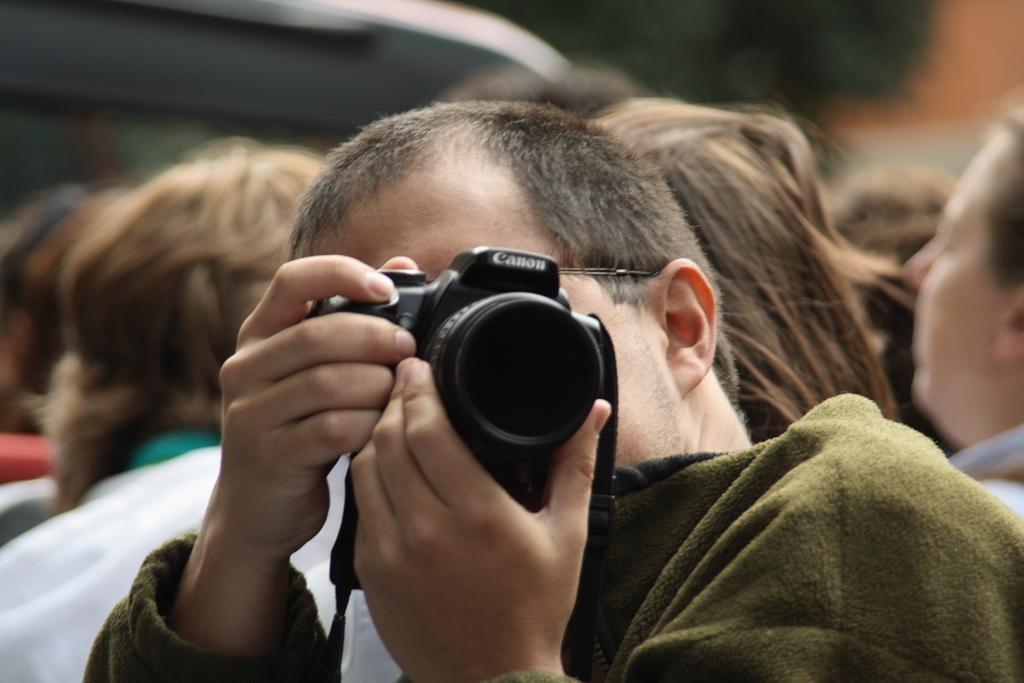Describe this image in one or two sentences. In this picture we can see a man who is holding a camera with his hands. On the background we can see some persons. 